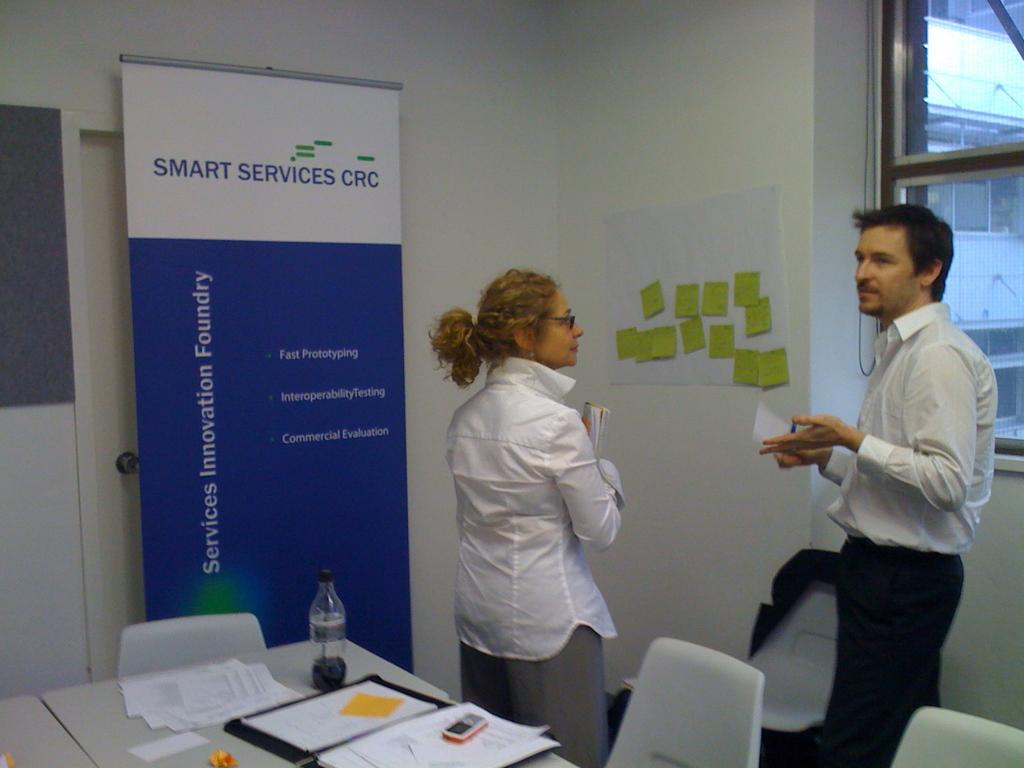<image>
Present a compact description of the photo's key features. a couple standing in front of a poster that says 'smart services crc' on it 